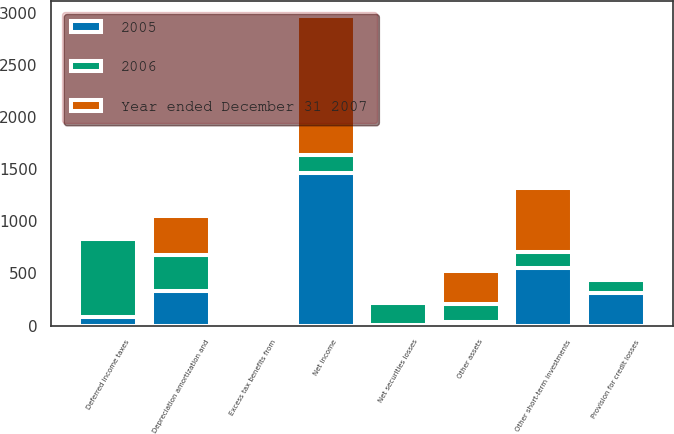Convert chart. <chart><loc_0><loc_0><loc_500><loc_500><stacked_bar_chart><ecel><fcel>Net income<fcel>Provision for credit losses<fcel>Depreciation amortization and<fcel>Deferred income taxes<fcel>Net securities losses<fcel>Excess tax benefits from<fcel>Other short-term investments<fcel>Other assets<nl><fcel>2005<fcel>1467<fcel>315<fcel>332<fcel>78<fcel>5<fcel>15<fcel>552<fcel>37<nl><fcel>2006<fcel>173<fcel>124<fcel>345<fcel>752<fcel>207<fcel>29<fcel>156<fcel>173<nl><fcel>Year ended December 31 2007<fcel>1325<fcel>21<fcel>375<fcel>1<fcel>41<fcel>4<fcel>613<fcel>315<nl></chart> 